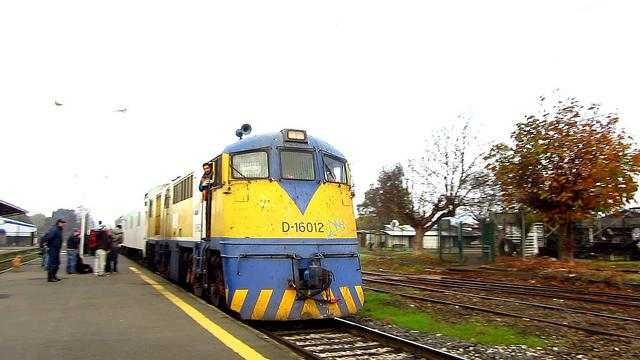What are the people waiting to do?

Choices:
A) pay
B) eat
C) play
D) board board 